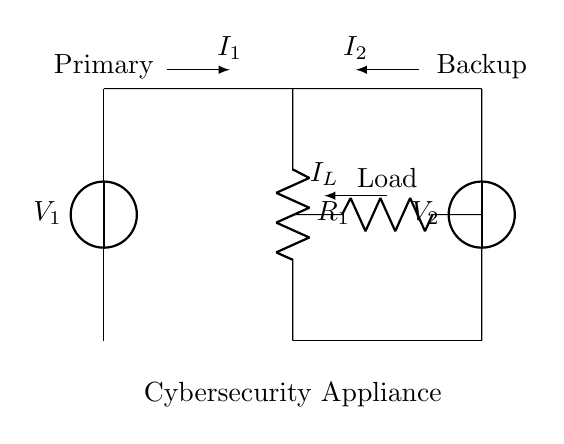What are the voltages of the power supplies in the circuit? The circuit diagram shows two power supplies labeled as V1 and V2. The specific values of these voltages are not stated in the diagram, but they represent the input voltages for the current divider circuit.
Answer: V1, V2 What is the role of the resistors in the diagram? The resistors in the circuit, labeled as R1 and Load, play a crucial role in the current division. R1 regulates the current between the two power supply branches, and Load acts as the load for the current flowing through the circuit.
Answer: Regulate current, load What is the current division principle in this circuit? The current division principle states that the current supplied by the voltage sources is split between the parallel paths inversely based on their resistance. The current flowing through each branch can be calculated using the formula Id = I_total * (R_total / R_branch), where R_branch corresponds to the respective resistances.
Answer: Inversely based on resistance Which component is responsible for supplying backup power? The component labeled as V2 is designated as the backup power supply. It acts in conjunction with the primary source V1 to ensure that the appliance receives power even if one source fails.
Answer: V2 What currents are present in the circuit, and how are they represented? The circuit diagram includes currents I1, I2, and IL, indicated by arrows. I1 represents the current through R1 from the primary source, I2 represents the current from the backup source, and IL represents the current flowing through the Load. These currents illustrate how the total current is divided between the power supplies and the load.
Answer: I1, I2, IL What is the significance of using a current divider in a cybersecurity appliance? The current divider is significant as it enables redundancy in power supply, ensuring that the cybersecurity appliance remains operational even if one power source fails. This redundancy is critical for maintaining uninterrupted operation and security in a cybersecurity context.
Answer: Redundancy in power supply 